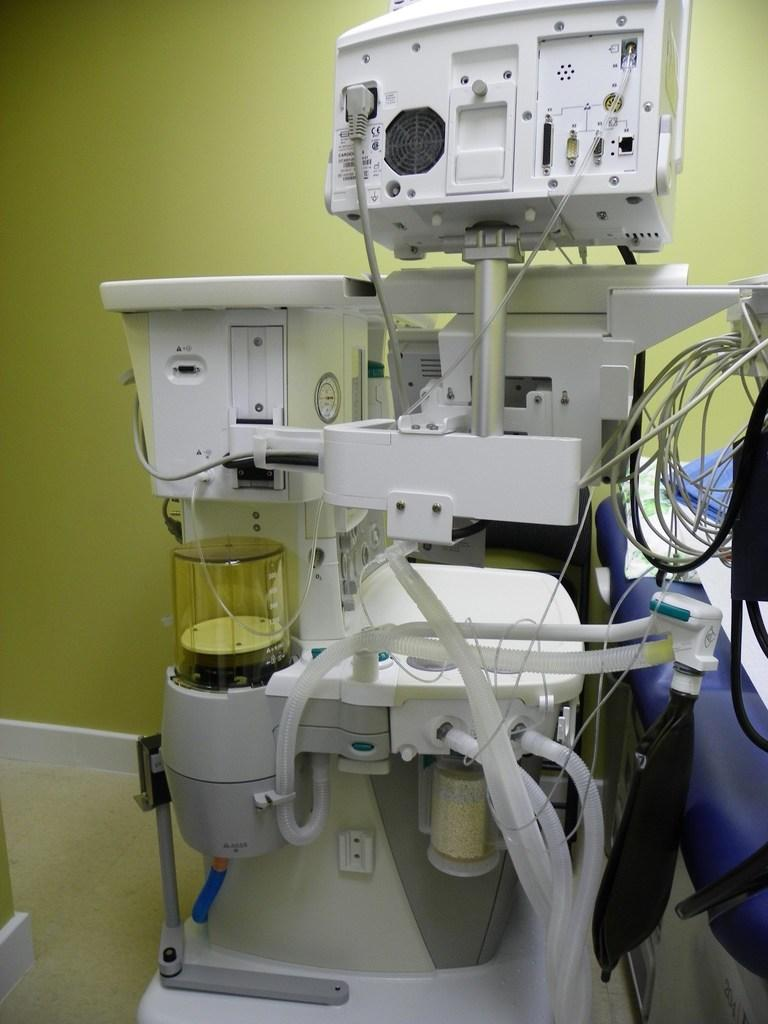What type of objects can be seen in the image? There are equipment and wires in the image. What color is the wall visible in the background? The wall in the background is yellow. What can be seen on the right side of the image? There is a blue color thing on the right side of the image. Can you tell me how many berries are hanging from the wires in the image? There are no berries present in the image; it features equipment and wires. What type of bell can be seen ringing on the yellow wall in the image? There is no bell present in the image; it features a yellow wall and equipment. 